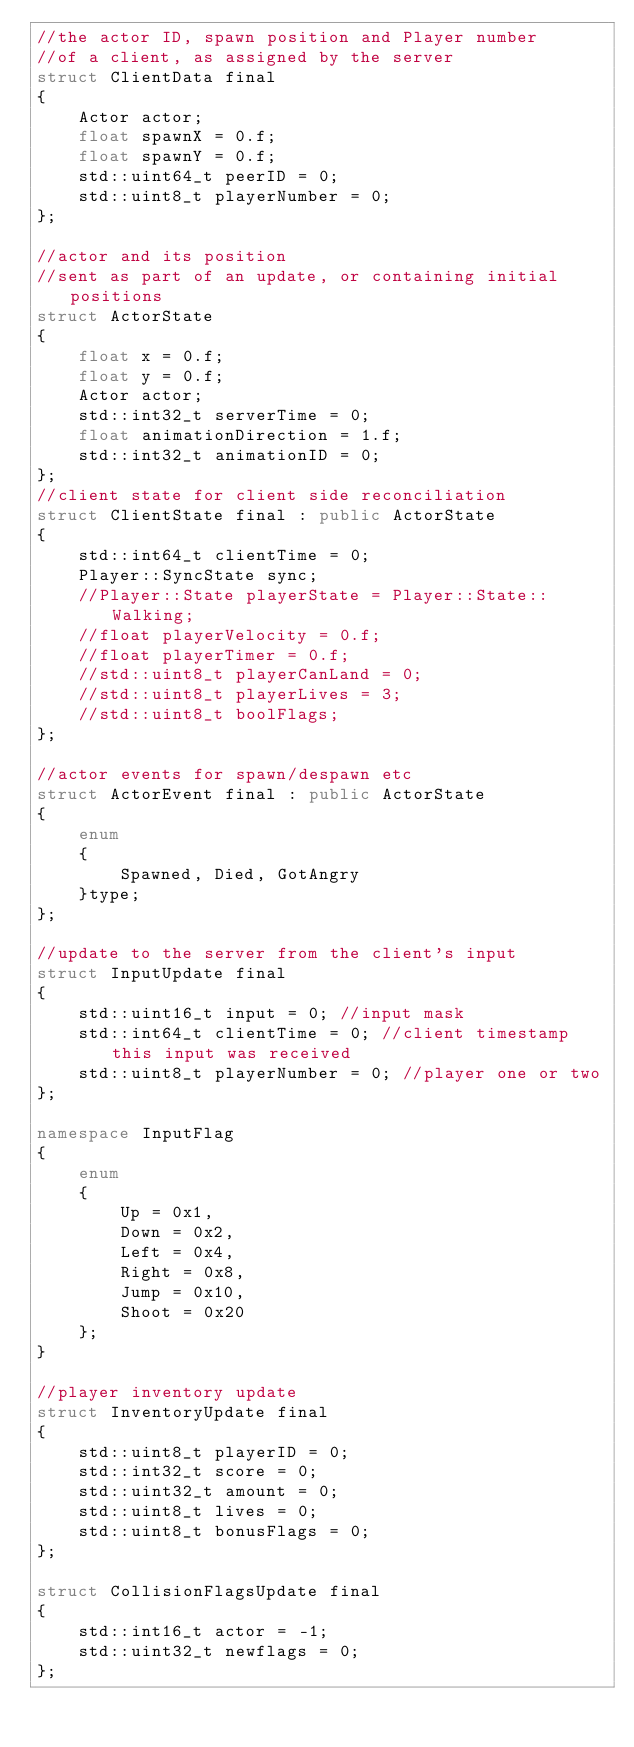<code> <loc_0><loc_0><loc_500><loc_500><_C++_>//the actor ID, spawn position and Player number
//of a client, as assigned by the server
struct ClientData final
{
    Actor actor;
    float spawnX = 0.f;
    float spawnY = 0.f;
    std::uint64_t peerID = 0;
    std::uint8_t playerNumber = 0;
};

//actor and its position
//sent as part of an update, or containing initial positions
struct ActorState
{
    float x = 0.f;
    float y = 0.f;
    Actor actor;
    std::int32_t serverTime = 0;
    float animationDirection = 1.f;
    std::int32_t animationID = 0;
};
//client state for client side reconciliation
struct ClientState final : public ActorState
{
    std::int64_t clientTime = 0;
    Player::SyncState sync;
    //Player::State playerState = Player::State::Walking;
    //float playerVelocity = 0.f;
    //float playerTimer = 0.f;
    //std::uint8_t playerCanLand = 0;
    //std::uint8_t playerLives = 3;
    //std::uint8_t boolFlags;
};

//actor events for spawn/despawn etc
struct ActorEvent final : public ActorState
{
    enum
    {
        Spawned, Died, GotAngry
    }type;
};

//update to the server from the client's input
struct InputUpdate final
{
    std::uint16_t input = 0; //input mask
    std::int64_t clientTime = 0; //client timestamp this input was received
    std::uint8_t playerNumber = 0; //player one or two
};

namespace InputFlag
{
    enum
    {
        Up = 0x1,
        Down = 0x2,
        Left = 0x4,
        Right = 0x8,
        Jump = 0x10,
        Shoot = 0x20
    };
}

//player inventory update
struct InventoryUpdate final
{
    std::uint8_t playerID = 0;
    std::int32_t score = 0;
    std::uint32_t amount = 0;
    std::uint8_t lives = 0;
    std::uint8_t bonusFlags = 0;
};

struct CollisionFlagsUpdate final
{
    std::int16_t actor = -1;
    std::uint32_t newflags = 0;
};
</code> 